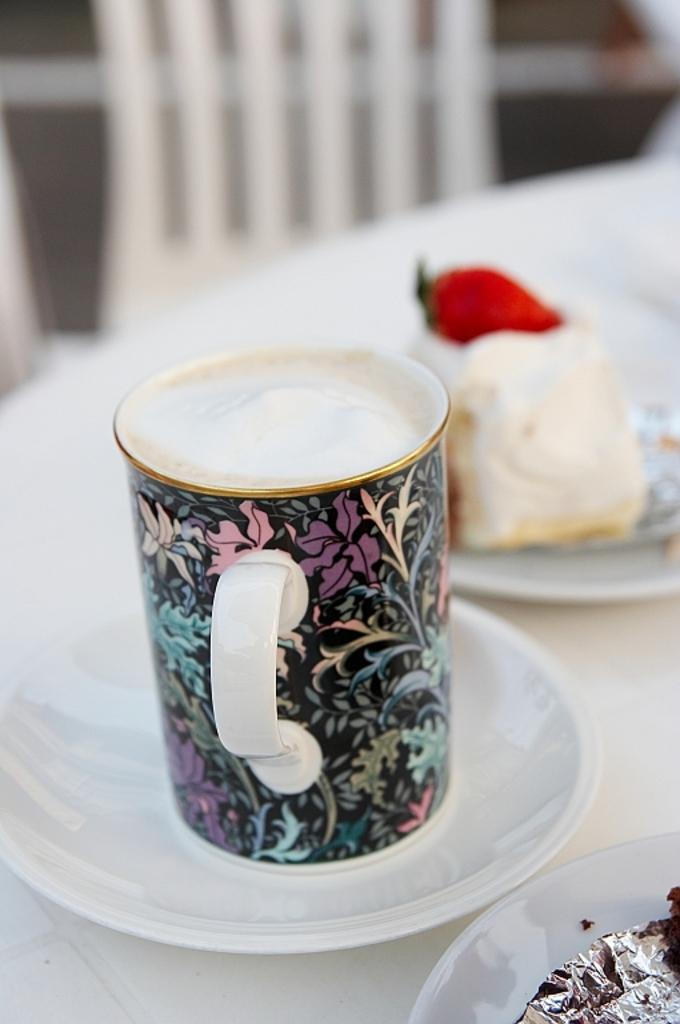What type of dishware is present in the image? There is a cup and a saucer in the image. What is on the plate in the image? There is food on a plate in the image. What type of furniture is visible in the image? There is a chair in the image. What type of lock is present on the chair in the image? There is no lock present on the chair in the image. What type of skin is visible on the food in the image? The food on the plate does not have skin; it is not a type of food that has skin. 